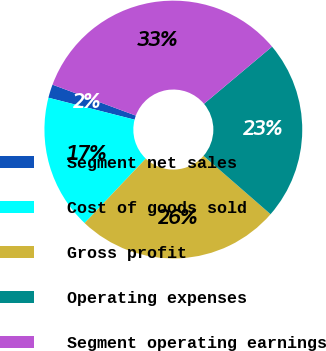<chart> <loc_0><loc_0><loc_500><loc_500><pie_chart><fcel>Segment net sales<fcel>Cost of goods sold<fcel>Gross profit<fcel>Operating expenses<fcel>Segment operating earnings<nl><fcel>1.69%<fcel>16.89%<fcel>25.68%<fcel>22.52%<fcel>33.22%<nl></chart> 